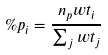Convert formula to latex. <formula><loc_0><loc_0><loc_500><loc_500>\% p _ { i } = \frac { n _ { p } w t _ { i } } { \sum _ { j } w t _ { j } }</formula> 